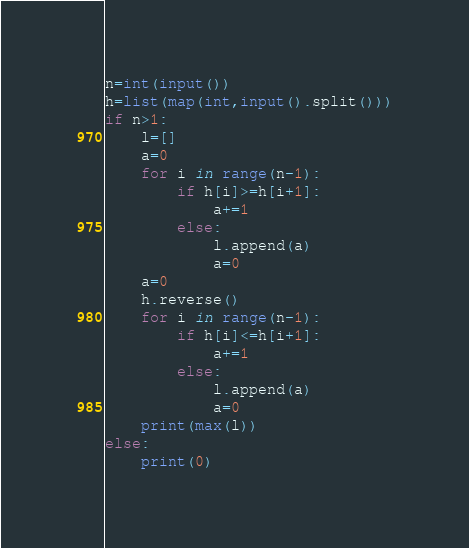<code> <loc_0><loc_0><loc_500><loc_500><_Python_>n=int(input())
h=list(map(int,input().split()))
if n>1:
    l=[]
    a=0
    for i in range(n-1):
        if h[i]>=h[i+1]:
            a+=1
        else:
            l.append(a)
            a=0
    a=0
    h.reverse()
    for i in range(n-1):
        if h[i]<=h[i+1]:
            a+=1
        else:
            l.append(a)
            a=0
    print(max(l))
else:
    print(0)
</code> 